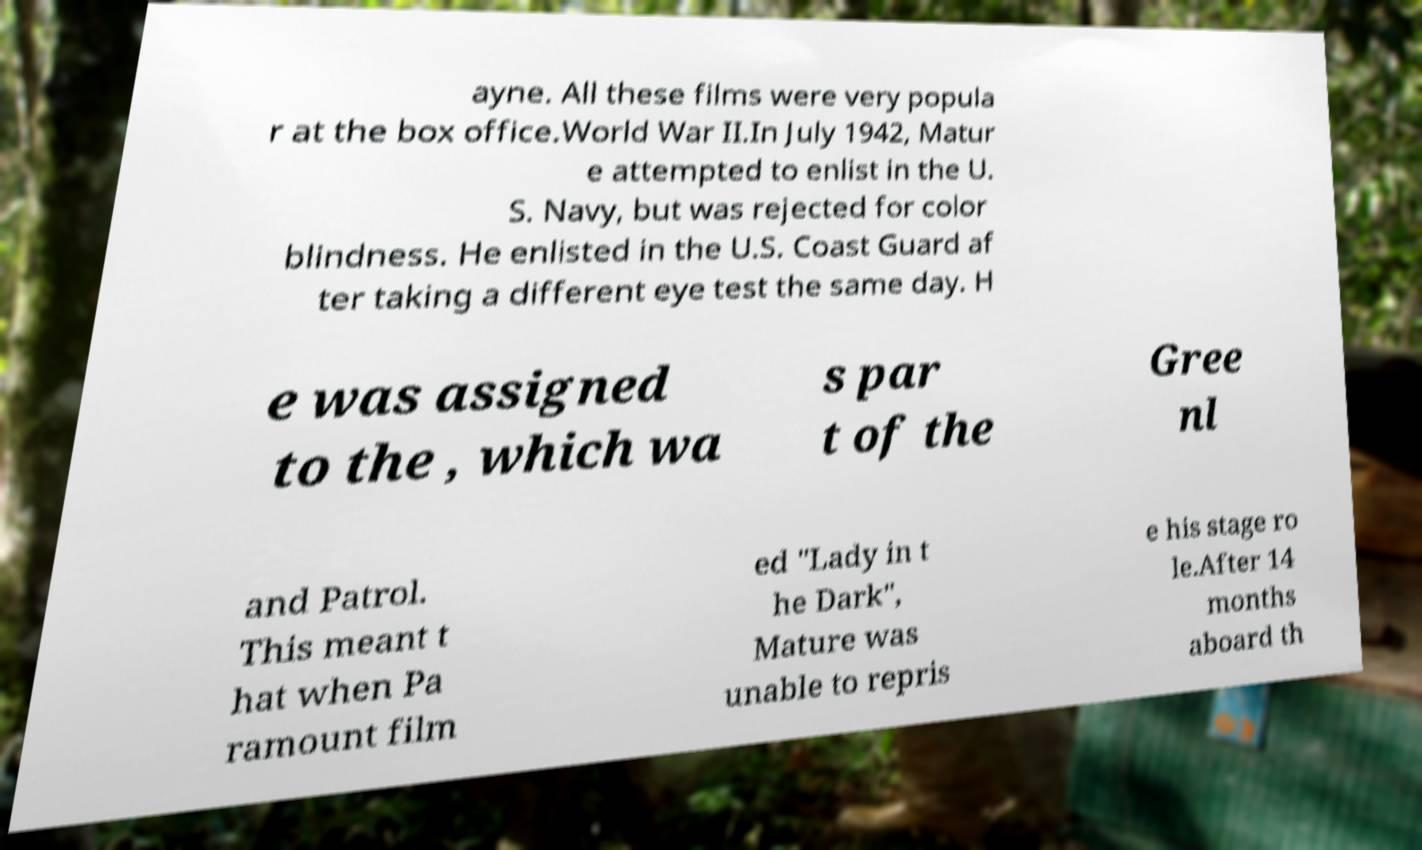Please read and relay the text visible in this image. What does it say? ayne. All these films were very popula r at the box office.World War II.In July 1942, Matur e attempted to enlist in the U. S. Navy, but was rejected for color blindness. He enlisted in the U.S. Coast Guard af ter taking a different eye test the same day. H e was assigned to the , which wa s par t of the Gree nl and Patrol. This meant t hat when Pa ramount film ed "Lady in t he Dark", Mature was unable to repris e his stage ro le.After 14 months aboard th 